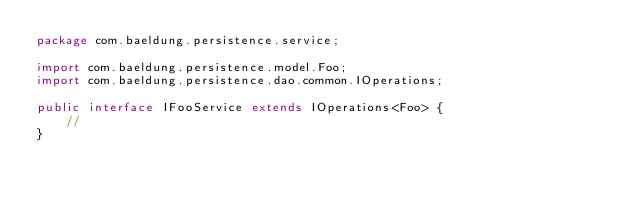<code> <loc_0><loc_0><loc_500><loc_500><_Java_>package com.baeldung.persistence.service;

import com.baeldung.persistence.model.Foo;
import com.baeldung.persistence.dao.common.IOperations;

public interface IFooService extends IOperations<Foo> {
    //
}
</code> 